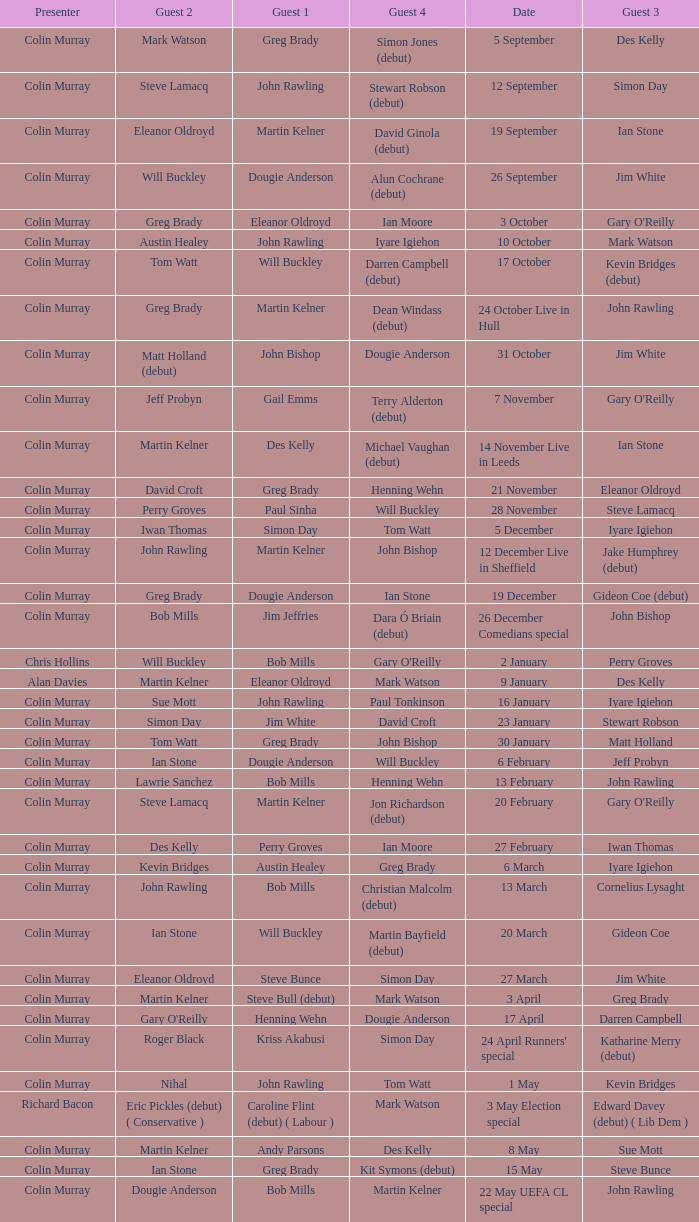On episodes where guest 1 is Jim White, who was guest 3? Stewart Robson. 